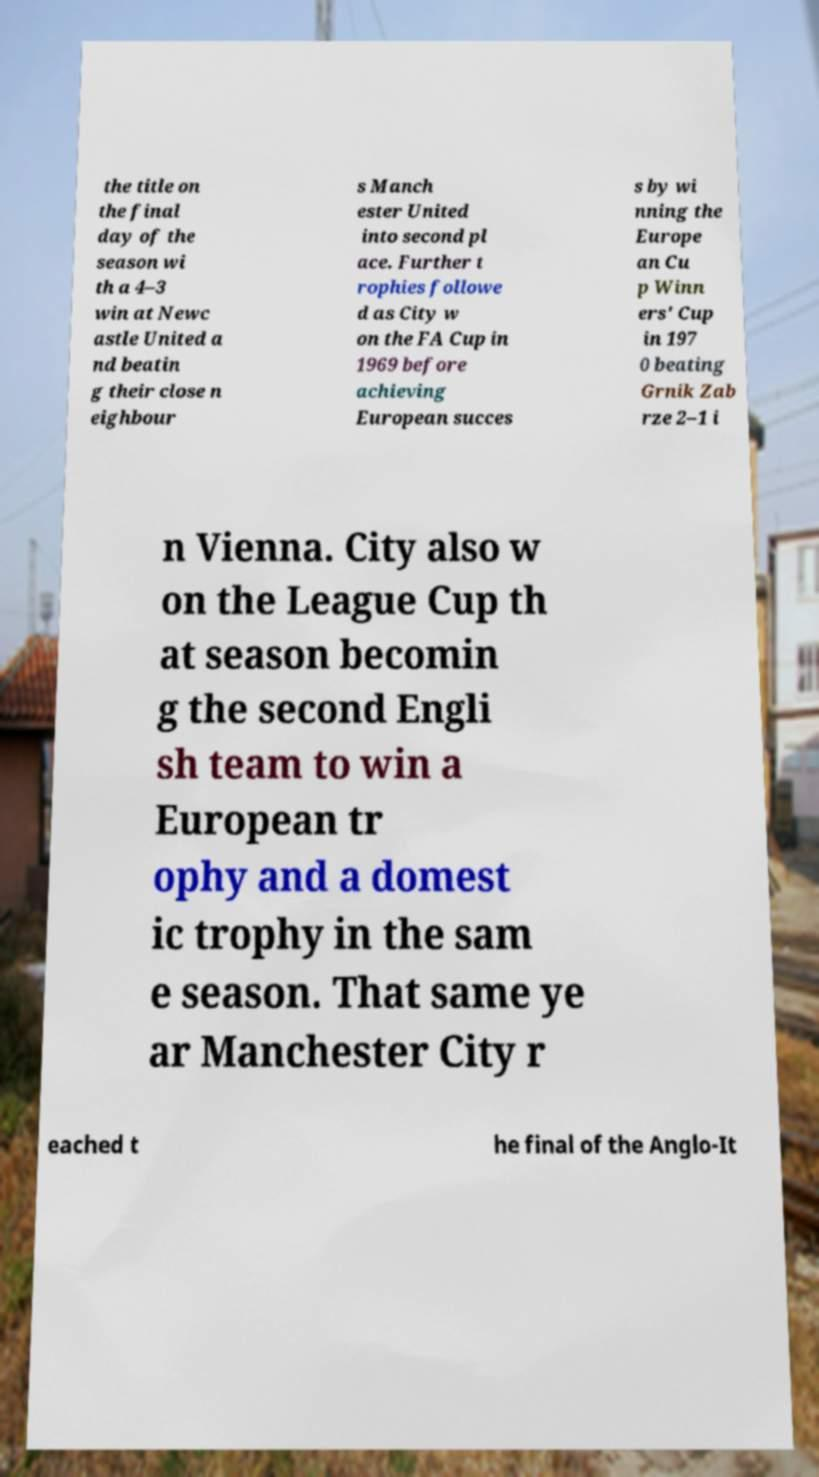For documentation purposes, I need the text within this image transcribed. Could you provide that? the title on the final day of the season wi th a 4–3 win at Newc astle United a nd beatin g their close n eighbour s Manch ester United into second pl ace. Further t rophies followe d as City w on the FA Cup in 1969 before achieving European succes s by wi nning the Europe an Cu p Winn ers' Cup in 197 0 beating Grnik Zab rze 2–1 i n Vienna. City also w on the League Cup th at season becomin g the second Engli sh team to win a European tr ophy and a domest ic trophy in the sam e season. That same ye ar Manchester City r eached t he final of the Anglo-It 